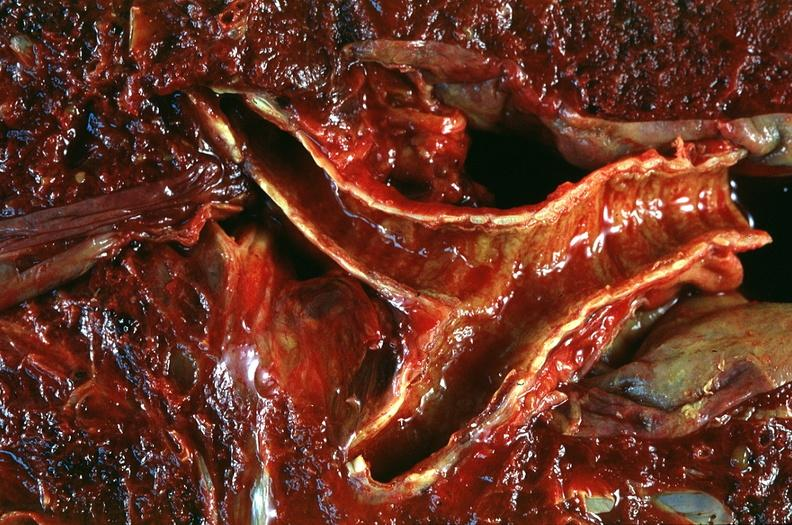where is this?
Answer the question using a single word or phrase. Lung 